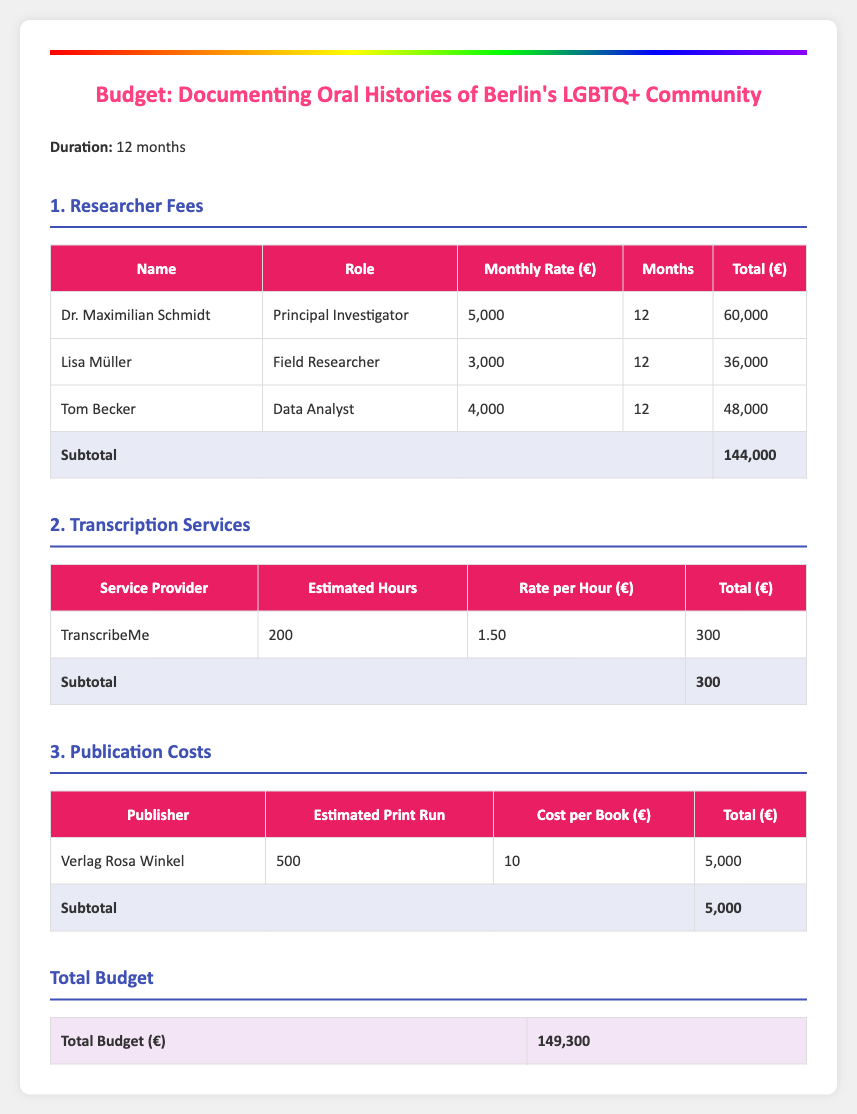What is the total budget? The total budget is the sum of all expense categories detailed in the document, which adds up to 149,300 euros.
Answer: 149,300 How many months is the project scheduled for? The project duration is specifically stated in the document as 12 months.
Answer: 12 months Who is the Principal Investigator? The document lists Dr. Maximilian Schmidt as the Principal Investigator in the researcher fees section.
Answer: Dr. Maximilian Schmidt What is the cost per book published by Verlag Rosa Winkel? The cost per book is detailed in the publication costs section as 10 euros.
Answer: 10 How much is allocated for transcription services? The total for transcription services is provided as 300 euros in the corresponding section.
Answer: 300 What is the total researcher fees? The total amount allocated for researcher fees is summed to 144,000 euros, detailed in the respective table.
Answer: 144,000 What is the estimated print run for the publication? The estimated print run is specified as 500 in the publication costs table.
Answer: 500 What is Lisa Müller's role in the project? The document categorizes Lisa Müller as the Field Researcher under researcher fees.
Answer: Field Researcher 